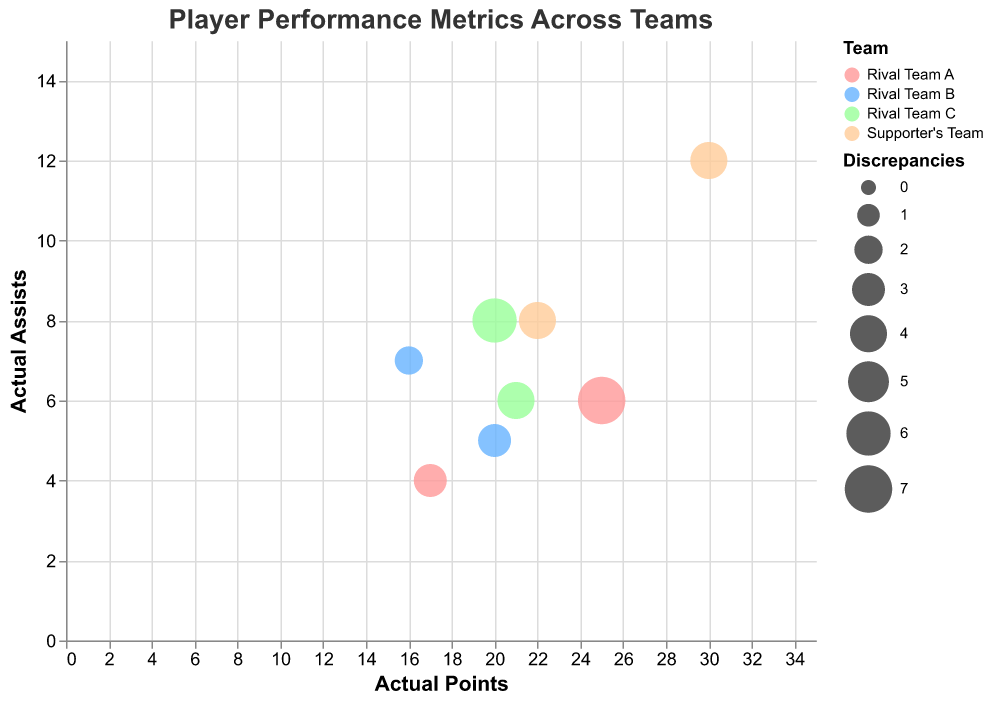How many players from "Rival Team B" have discrepancies greater than 2? We need to count the players from "Rival Team B" whose discrepancies are greater than 2. James Brown has 3 discrepancies and Ronald Green has 2. Since we are looking for discrepancies greater than 2, only James Brown qualifies.
Answer: 1 Which team has the highest number of discrepancies overall? We sum the discrepancies for each team. Rival Team A: 7 + 3 = 10, Rival Team B: 3 + 2 = 5, Rival Team C: 6 + 4 = 10, Supporter's Team: 4 + 4 = 8. Since Rival Team A and Rival Team C both have the highest total discrepancies (10), either team is correct.
Answer: Rival Team A or Rival Team C Which player has the highest actual points? We look at the "Actual Points" values and identify the highest. Chris White from Supporter's Team has 30 actual points, which is the highest.
Answer: Chris White What is the discrepancy for William Johnson from Rival Team C? From the data, William Johnson's discrepancy is given directly as 6.
Answer: 6 What is the average of the actual assists among all players from "Supporter's Team"? We sum the "Actual Assists" values for Chris White and Daniel Harris in Supporter's Team, which are 12 and 8, respectively, and then divide by the number of players (2). (12 + 8) / 2 = 10.
Answer: 10 How does Ronald Green’s discrepancy compare to Chris White’s? Ronald Green's discrepancy is 2, and Chris White's discrepancy is 4. Since Ronald Green's discrepancy is smaller, he has fewer discrepancies.
Answer: Ronald Green has fewer discrepancies Which player's data point represents the largest bubble in the bubble chart? The largest bubble in a bubble chart is represented by the player with the highest discrepancy value. John Doe from Rival Team A has the highest discrepancy of 7.
Answer: John Doe Do players from "Supporter's Team" generally have higher or lower actual points compared to "Rival Team A" players? We compare the actual points of players from both teams. Supporter's Team players, Chris White and Daniel Harris, have 30 and 22 actual points, respectively, averaging to (30 + 22)/2 = 26. Rival Team A players, John Doe and Mark Smith, have 25 and 17 actual points, respectively, averaging to (25 + 17)/2 = 21. Supporter's Team has a higher average.
Answer: Higher What is the sum of the discrepancies for players from "Rival Team C"? We sum the "Discrepancies" values for William Johnson and Michael Davis from Rival Team C, which are 6 and 4. 6 + 4 = 10.
Answer: 10 